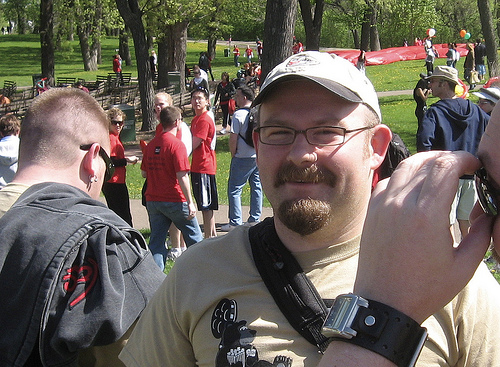<image>
Can you confirm if the cap is on the man? Yes. Looking at the image, I can see the cap is positioned on top of the man, with the man providing support. 